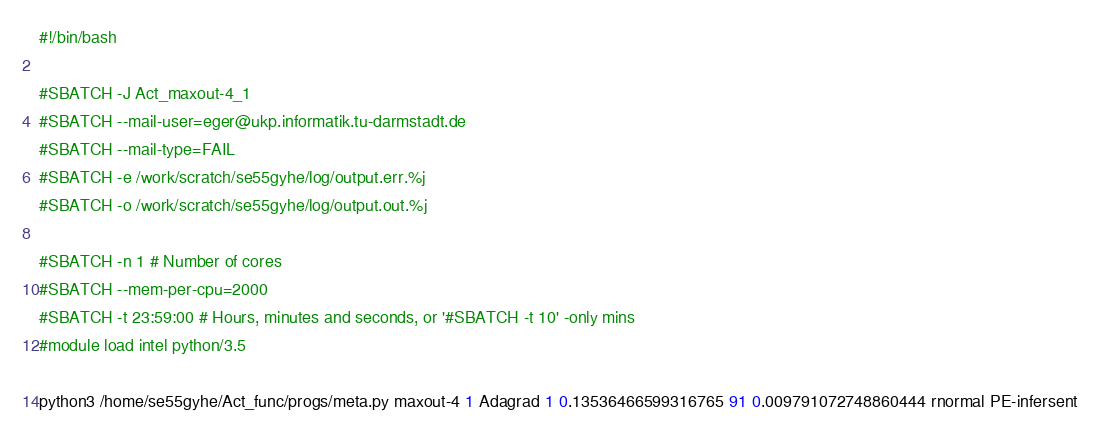Convert code to text. <code><loc_0><loc_0><loc_500><loc_500><_Bash_>#!/bin/bash
 
#SBATCH -J Act_maxout-4_1
#SBATCH --mail-user=eger@ukp.informatik.tu-darmstadt.de
#SBATCH --mail-type=FAIL
#SBATCH -e /work/scratch/se55gyhe/log/output.err.%j
#SBATCH -o /work/scratch/se55gyhe/log/output.out.%j

#SBATCH -n 1 # Number of cores
#SBATCH --mem-per-cpu=2000
#SBATCH -t 23:59:00 # Hours, minutes and seconds, or '#SBATCH -t 10' -only mins
#module load intel python/3.5

python3 /home/se55gyhe/Act_func/progs/meta.py maxout-4 1 Adagrad 1 0.13536466599316765 91 0.009791072748860444 rnormal PE-infersent 

</code> 